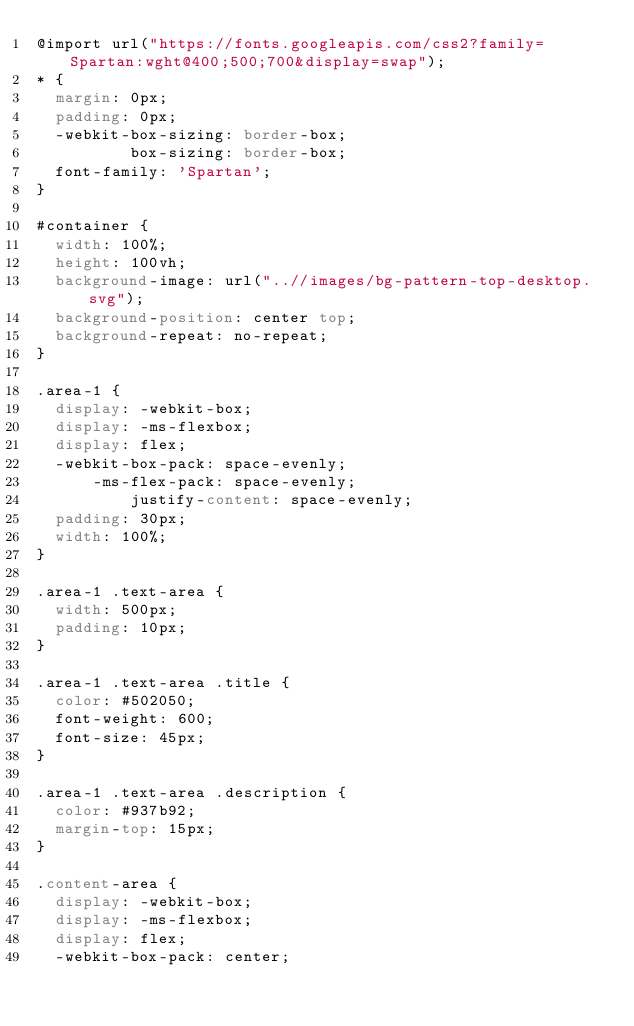<code> <loc_0><loc_0><loc_500><loc_500><_CSS_>@import url("https://fonts.googleapis.com/css2?family=Spartan:wght@400;500;700&display=swap");
* {
  margin: 0px;
  padding: 0px;
  -webkit-box-sizing: border-box;
          box-sizing: border-box;
  font-family: 'Spartan';
}

#container {
  width: 100%;
  height: 100vh;
  background-image: url("..//images/bg-pattern-top-desktop.svg");
  background-position: center top;
  background-repeat: no-repeat;
}

.area-1 {
  display: -webkit-box;
  display: -ms-flexbox;
  display: flex;
  -webkit-box-pack: space-evenly;
      -ms-flex-pack: space-evenly;
          justify-content: space-evenly;
  padding: 30px;
  width: 100%;
}

.area-1 .text-area {
  width: 500px;
  padding: 10px;
}

.area-1 .text-area .title {
  color: #502050;
  font-weight: 600;
  font-size: 45px;
}

.area-1 .text-area .description {
  color: #937b92;
  margin-top: 15px;
}

.content-area {
  display: -webkit-box;
  display: -ms-flexbox;
  display: flex;
  -webkit-box-pack: center;</code> 